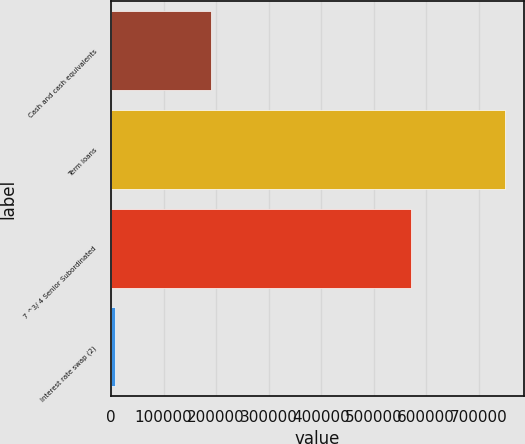Convert chart. <chart><loc_0><loc_0><loc_500><loc_500><bar_chart><fcel>Cash and cash equivalents<fcel>Term loans<fcel>7 ^3/ 4 Senior Subordinated<fcel>Interest rate swap (2)<nl><fcel>190167<fcel>749000<fcel>571000<fcel>7787<nl></chart> 